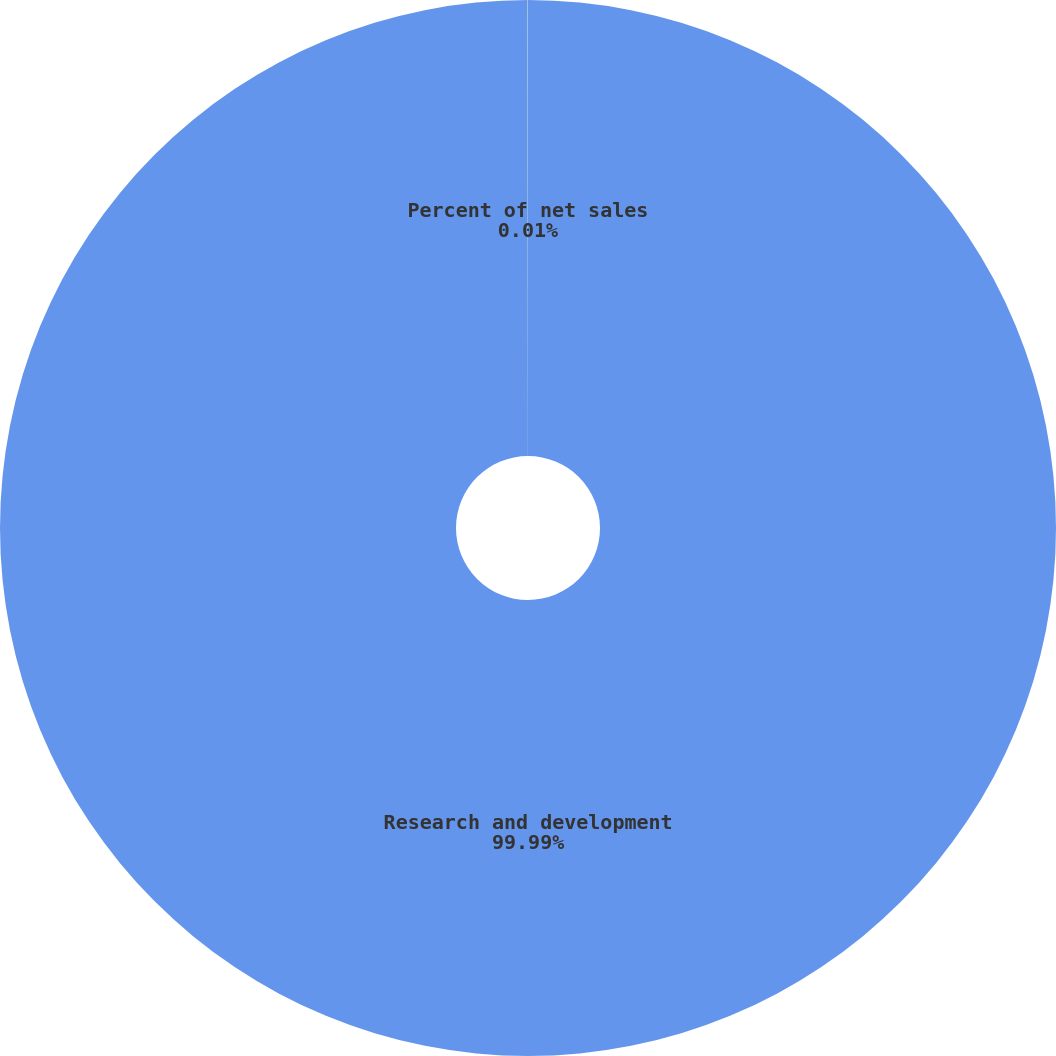Convert chart. <chart><loc_0><loc_0><loc_500><loc_500><pie_chart><fcel>Research and development<fcel>Percent of net sales<nl><fcel>99.99%<fcel>0.01%<nl></chart> 